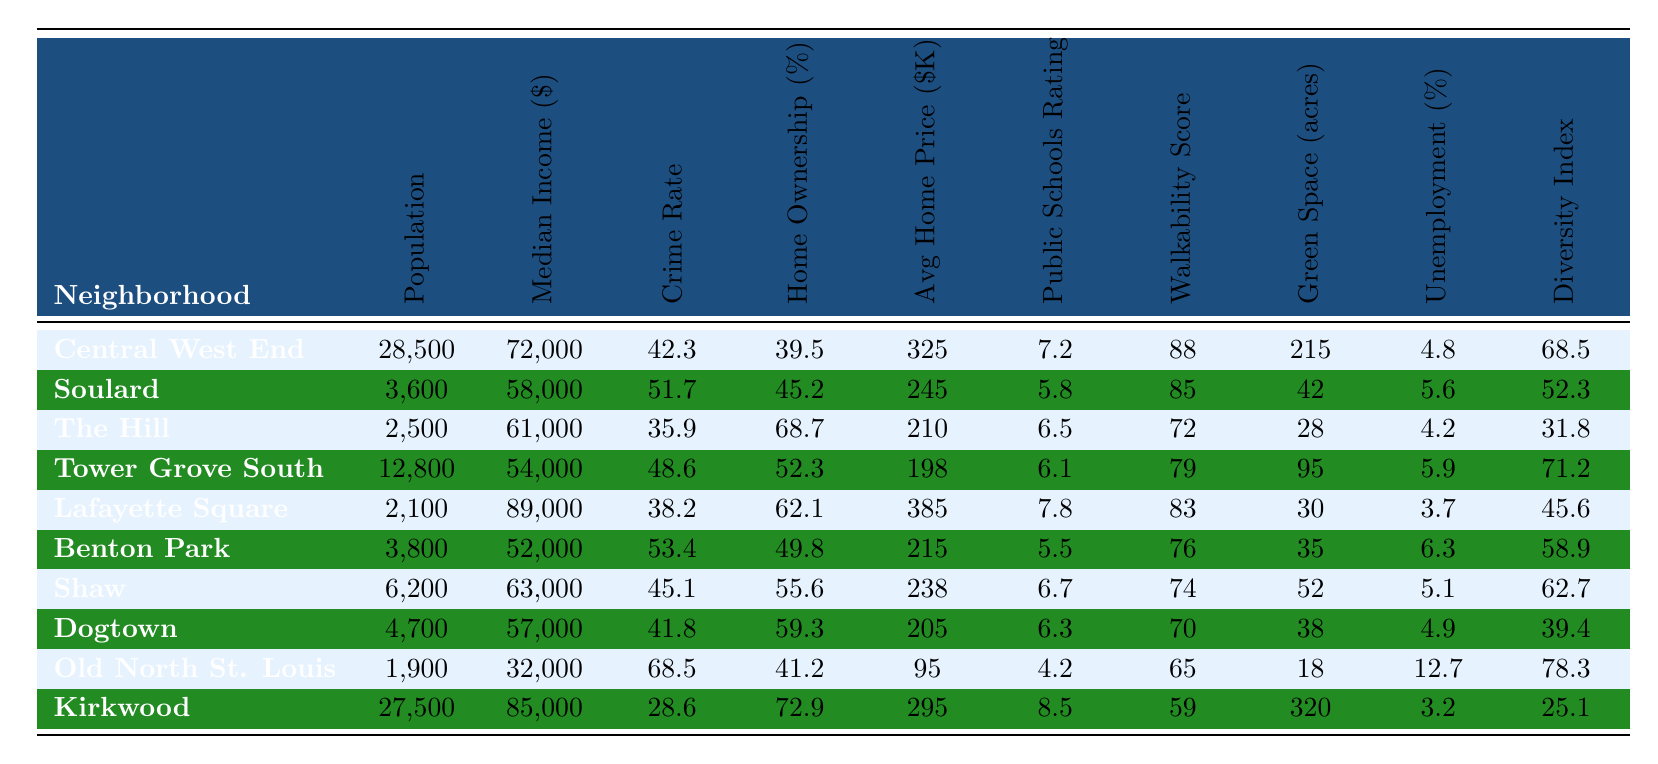What is the median income of Central West End? The table shows that the median income for Central West End is listed as \$72,000.
Answer: \$72,000 Which neighborhood has the highest crime rate? By examining the crime rates in the table, Old North St. Louis has the highest rate at 68.5.
Answer: Old North St. Louis How do the average home prices of Kirkwood and Lafayette Square compare? The average home price for Kirkwood is \$295,000 and for Lafayette Square it is \$385,000. When comparing, Lafayette Square's average home price is higher.
Answer: Lafayette Square has a higher average home price What is the average home price of the neighborhoods with a population under 5000? The neighborhoods with populations under 5000 are The Hill (2,500), Old North St. Louis (1,900), and Dogtown (4,700). Their average home prices are \$210,000, \$95,000, and \$205,000. The average is (210 + 95 + 205) / 3 = 168.33.
Answer: \$168,333 Is the home ownership rate in Shaw higher than that in Benton Park? The table shows Shaw's home ownership rate is 55.6% while Benton Park's is 49.8%, which means Shaw's rate is indeed higher.
Answer: Yes Which neighborhood has the largest area of green space? From the table, Kirkwood has the largest green space at 320 acres compared to other neighborhoods.
Answer: Kirkwood What is the difference in median income between Kirkwood and Soulard? Kirkwood's median income is \$85,000 and Soulard's is \$58,000. The difference is calculated as 85,000 - 58,000 = 27,000.
Answer: \$27,000 How many neighborhoods have a public schools rating above 7? By checking the table, the neighborhoods are Central West End (7.2), Lafayette Square (7.8), and Kirkwood (8.5). This totals three neighborhoods with ratings above 7.
Answer: 3 neighborhoods What is the lowest unemployment rate listed and in which neighborhood does it occur? The unemployment rates are 4.8 (Central West End), 5.6 (Soulard), 4.2 (The Hill), 5.9 (Tower Grove South), 3.7 (Lafayette Square), 6.3 (Benton Park), 5.1 (Shaw), 4.9 (Dogtown), 12.7 (Old North St. Louis), and 3.2 (Kirkwood). The lowest is 3.2 in Kirkwood.
Answer: 3.2 in Kirkwood Which neighborhood has both a higher walkability score and a median income than Tower Grove South? Tower Grove South's walkability score is 79 and median income is \$54,000. Central West End (88, 72,000) and Kirkwood (59, 85,000) meet these criteria, as they both have higher scores and incomes.
Answer: Central West End and Kirkwood 